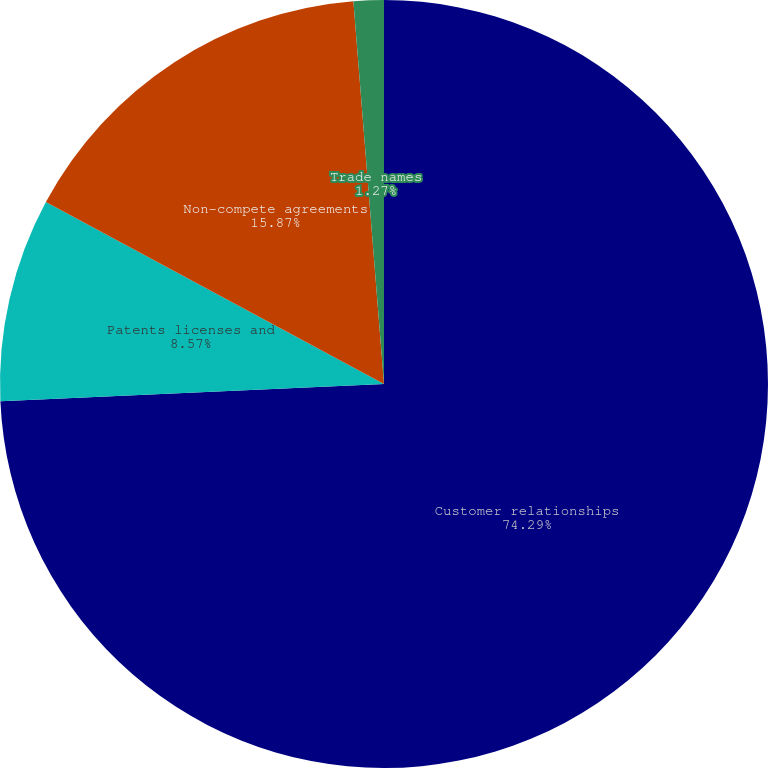Convert chart to OTSL. <chart><loc_0><loc_0><loc_500><loc_500><pie_chart><fcel>Customer relationships<fcel>Patents licenses and<fcel>Non-compete agreements<fcel>Trade names<nl><fcel>74.28%<fcel>8.57%<fcel>15.87%<fcel>1.27%<nl></chart> 